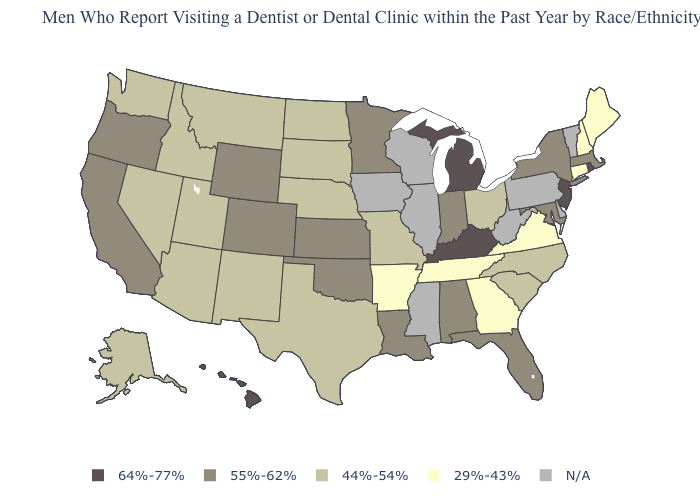What is the highest value in states that border Missouri?
Short answer required. 64%-77%. What is the value of Rhode Island?
Short answer required. 64%-77%. Which states have the lowest value in the USA?
Be succinct. Arkansas, Connecticut, Georgia, Maine, New Hampshire, Tennessee, Virginia. Does the map have missing data?
Quick response, please. Yes. What is the value of Montana?
Be succinct. 44%-54%. Name the states that have a value in the range N/A?
Quick response, please. Delaware, Illinois, Iowa, Mississippi, Pennsylvania, Vermont, West Virginia, Wisconsin. Does Nevada have the highest value in the USA?
Concise answer only. No. Does New Hampshire have the lowest value in the Northeast?
Give a very brief answer. Yes. Name the states that have a value in the range 55%-62%?
Be succinct. Alabama, California, Colorado, Florida, Indiana, Kansas, Louisiana, Maryland, Massachusetts, Minnesota, New York, Oklahoma, Oregon, Wyoming. What is the lowest value in the USA?
Answer briefly. 29%-43%. Name the states that have a value in the range N/A?
Keep it brief. Delaware, Illinois, Iowa, Mississippi, Pennsylvania, Vermont, West Virginia, Wisconsin. How many symbols are there in the legend?
Answer briefly. 5. Is the legend a continuous bar?
Keep it brief. No. Among the states that border Maine , which have the lowest value?
Quick response, please. New Hampshire. What is the highest value in states that border Kentucky?
Keep it brief. 55%-62%. 